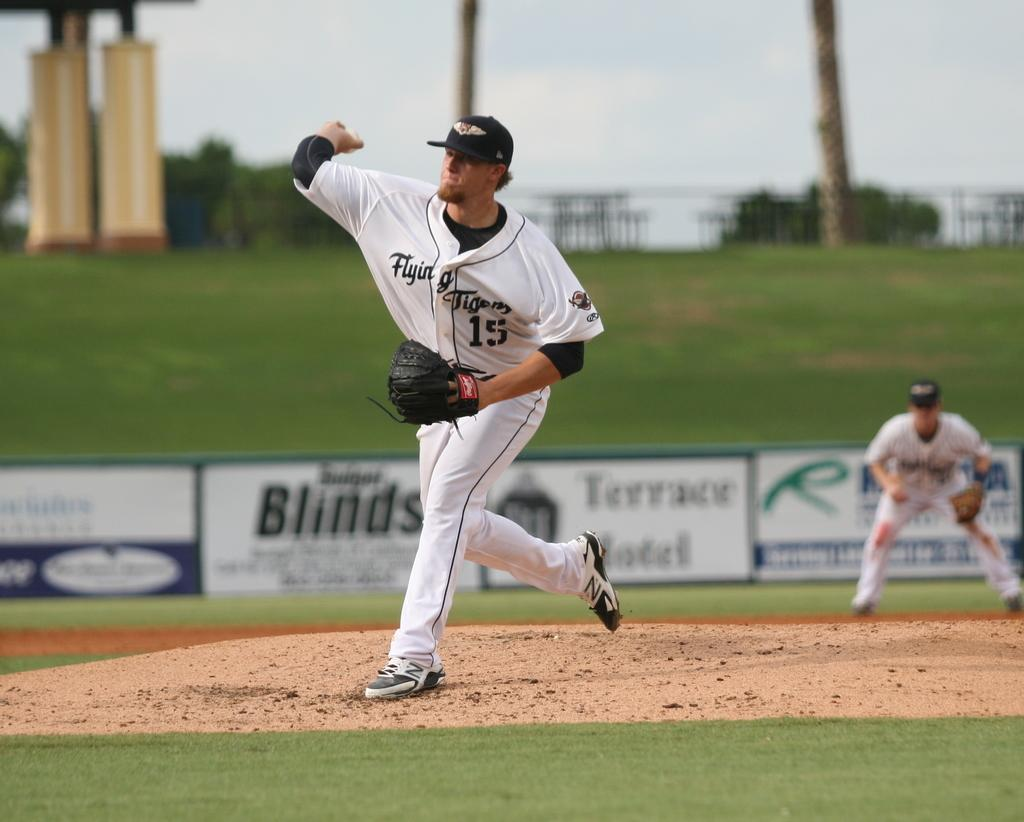<image>
Summarize the visual content of the image. A pitcher for the Flying Tigers team wears number 15. 